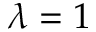Convert formula to latex. <formula><loc_0><loc_0><loc_500><loc_500>\lambda = 1</formula> 